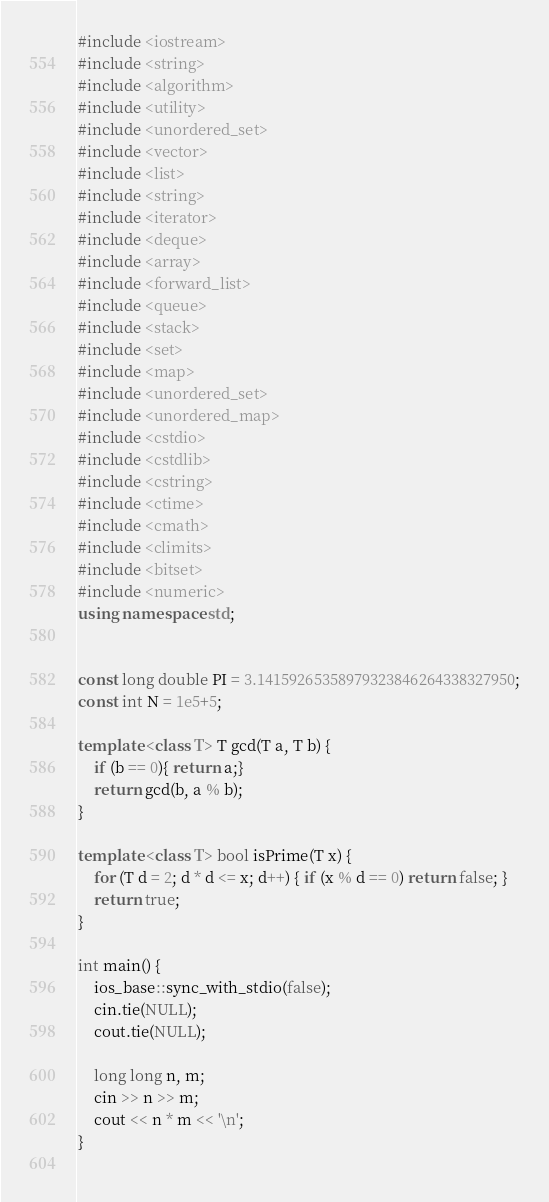<code> <loc_0><loc_0><loc_500><loc_500><_C++_>#include <iostream>
#include <string>
#include <algorithm>
#include <utility> 
#include <unordered_set>
#include <vector>
#include <list> 
#include <string>
#include <iterator> 
#include <deque>
#include <array>
#include <forward_list>
#include <queue>
#include <stack>
#include <set>
#include <map>
#include <unordered_set>
#include <unordered_map>
#include <cstdio>
#include <cstdlib>
#include <cstring>
#include <ctime>
#include <cmath>
#include <climits>
#include <bitset>
#include <numeric>
using namespace std;


const long double PI = 3.14159265358979323846264338327950;
const int N = 1e5+5;

template <class T> T gcd(T a, T b) {
	if (b == 0){ return a;} 
	return gcd(b, a % b);
}

template <class T> bool isPrime(T x) {
	for (T d = 2; d * d <= x; d++) { if (x % d == 0) return false; }
	return true;
}

int main() {
	ios_base::sync_with_stdio(false);
	cin.tie(NULL);
	cout.tie(NULL);
		
	long long n, m;
	cin >> n >> m;
	cout << n * m << '\n';
}
		</code> 